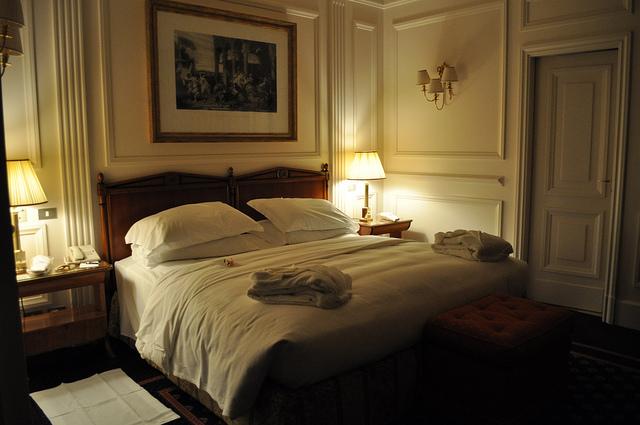What is the percentage of lamps turned on in the room?
Keep it brief. 100%. How many beds are here?
Short answer required. 1. Is that a chest at the end of the bed?
Write a very short answer. No. How many framed pictures are on the wall?
Be succinct. 1. Is there a fireplace in the room?
Write a very short answer. No. What color is the bedspread?
Concise answer only. White. How many pillows on the bed?
Write a very short answer. 4. What is the dominant color in the rug?
Quick response, please. White. Does this room look ready for a romantic interlude?
Be succinct. Yes. How many windows are in the room?
Short answer required. 0. Which room is this?
Short answer required. Bedroom. Is there a window in the room?
Give a very brief answer. No. How many fish are on the bed?
Be succinct. 0. Is this scene in a hotel?
Answer briefly. Yes. 